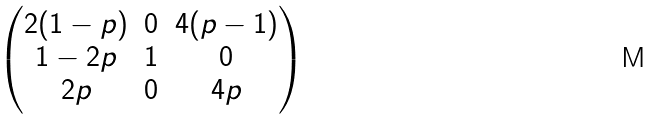Convert formula to latex. <formula><loc_0><loc_0><loc_500><loc_500>\begin{pmatrix} 2 ( 1 - p ) & 0 & 4 ( p - 1 ) \\ 1 - 2 p & 1 & 0 \\ 2 p & 0 & 4 p \end{pmatrix}</formula> 